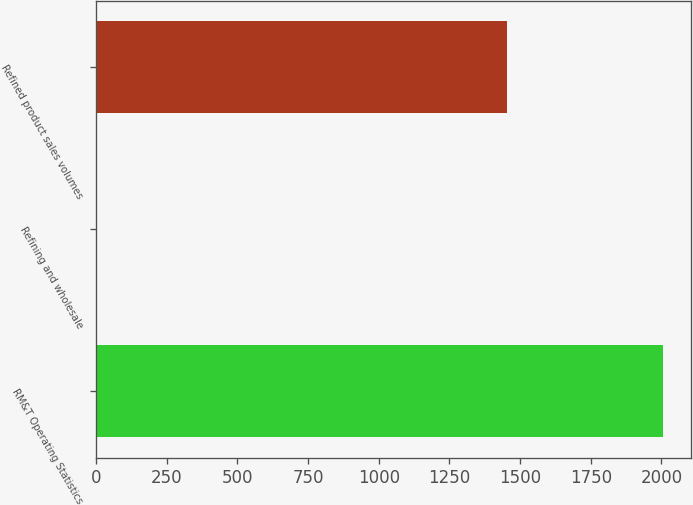<chart> <loc_0><loc_0><loc_500><loc_500><bar_chart><fcel>RM&T Operating Statistics<fcel>Refining and wholesale<fcel>Refined product sales volumes<nl><fcel>2005<fcel>0.16<fcel>1455<nl></chart> 